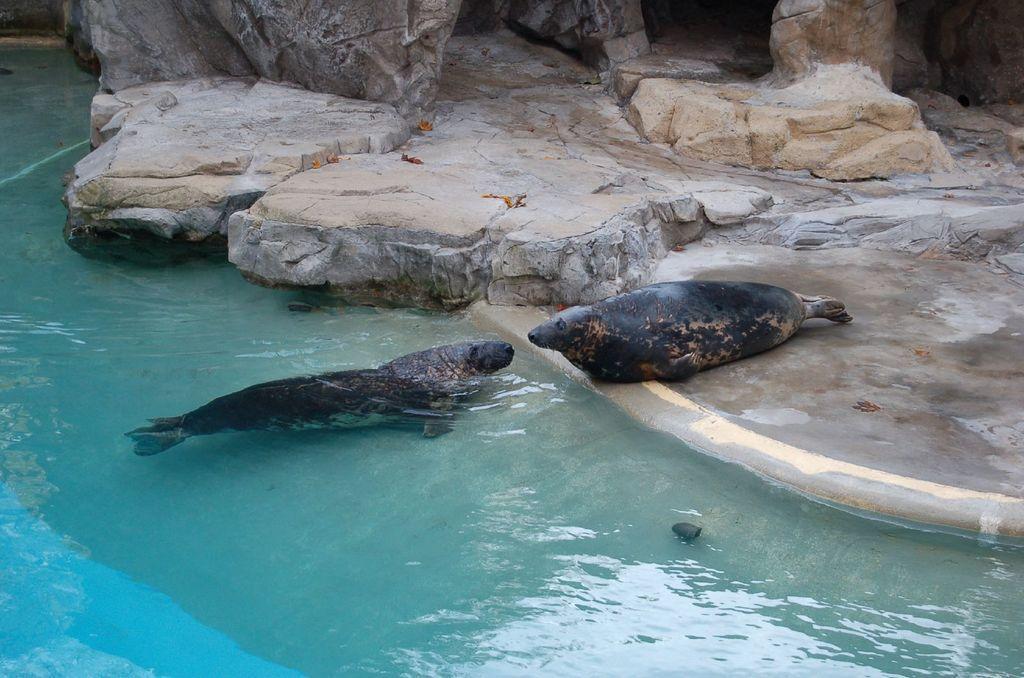In one or two sentences, can you explain what this image depicts? On the left side of the image there is water with a seal in it. In front of that there is an another seal on the land. In the background there are rocks. 